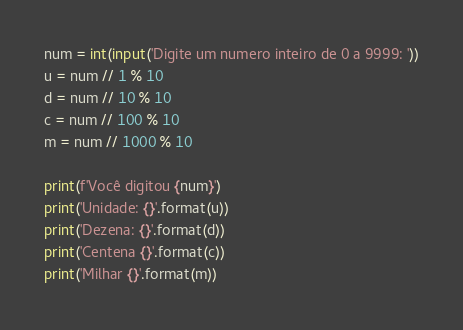<code> <loc_0><loc_0><loc_500><loc_500><_Python_>num = int(input('Digite um numero inteiro de 0 a 9999: '))
u = num // 1 % 10
d = num // 10 % 10
c = num // 100 % 10
m = num // 1000 % 10

print(f'Você digitou {num}')
print('Unidade: {}'.format(u))
print('Dezena: {}'.format(d))
print('Centena {}'.format(c))
print('Milhar {}'.format(m))

</code> 